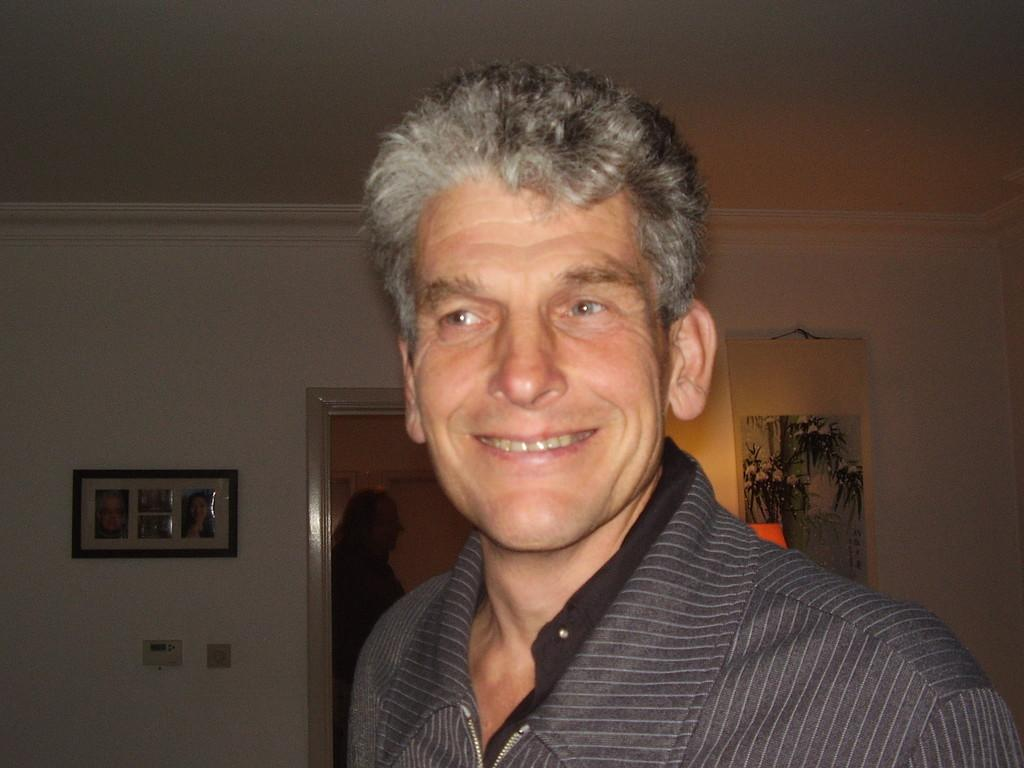Who is present in the image? There is a man in the image. What is the man doing in the image? The man is smiling in the image. What can be seen in the background of the image? There are frames on the wall in the background of the image. What type of rhythm is the man playing on the stage in the image? There is no stage or rhythm present in the image; it features a man smiling with frames on the wall in the background. 